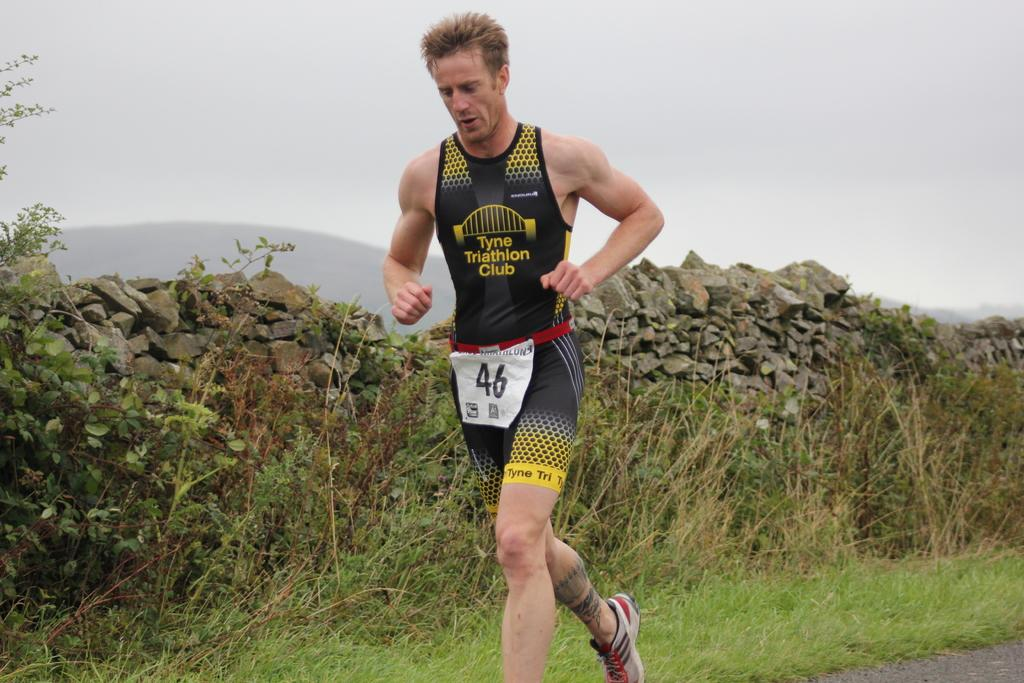<image>
Render a clear and concise summary of the photo. Runner number 46 is wearing black and yellow and running through grass. 